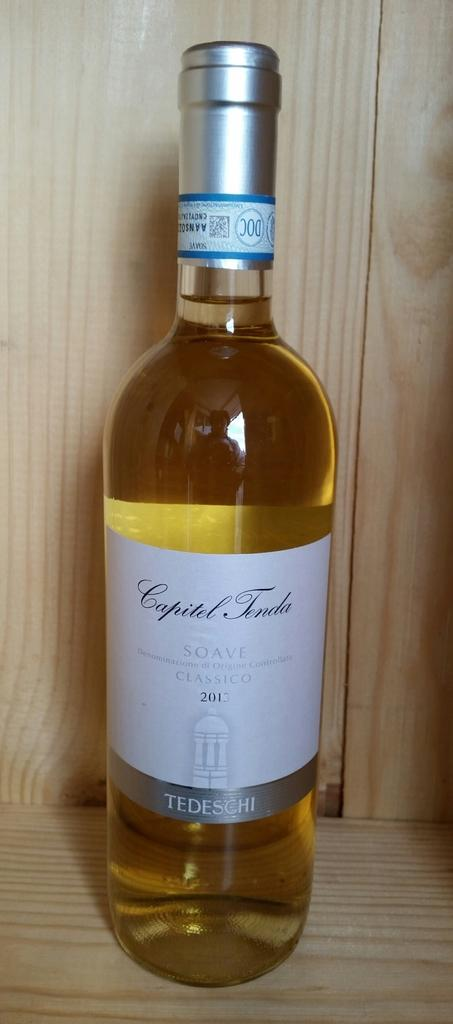<image>
Relay a brief, clear account of the picture shown. A bottle of Capitel Tenda Soave wine sits on a shelf 